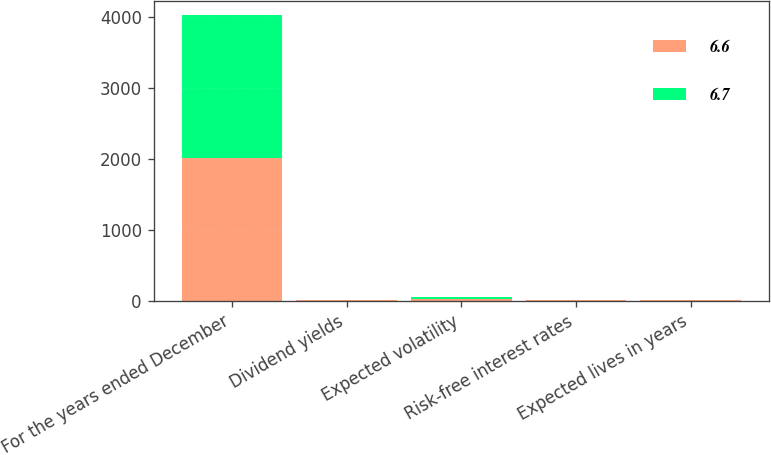Convert chart to OTSL. <chart><loc_0><loc_0><loc_500><loc_500><stacked_bar_chart><ecel><fcel>For the years ended December<fcel>Dividend yields<fcel>Expected volatility<fcel>Risk-free interest rates<fcel>Expected lives in years<nl><fcel>6.6<fcel>2014<fcel>2<fcel>22.3<fcel>2.1<fcel>6.7<nl><fcel>6.7<fcel>2013<fcel>2.2<fcel>22.2<fcel>1.4<fcel>6.6<nl></chart> 